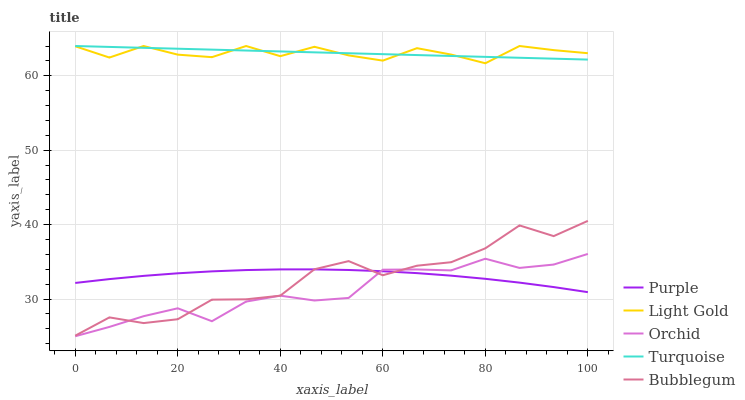Does Orchid have the minimum area under the curve?
Answer yes or no. Yes. Does Turquoise have the maximum area under the curve?
Answer yes or no. Yes. Does Light Gold have the minimum area under the curve?
Answer yes or no. No. Does Light Gold have the maximum area under the curve?
Answer yes or no. No. Is Turquoise the smoothest?
Answer yes or no. Yes. Is Bubblegum the roughest?
Answer yes or no. Yes. Is Light Gold the smoothest?
Answer yes or no. No. Is Light Gold the roughest?
Answer yes or no. No. Does Orchid have the lowest value?
Answer yes or no. Yes. Does Light Gold have the lowest value?
Answer yes or no. No. Does Light Gold have the highest value?
Answer yes or no. Yes. Does Bubblegum have the highest value?
Answer yes or no. No. Is Bubblegum less than Light Gold?
Answer yes or no. Yes. Is Light Gold greater than Purple?
Answer yes or no. Yes. Does Orchid intersect Purple?
Answer yes or no. Yes. Is Orchid less than Purple?
Answer yes or no. No. Is Orchid greater than Purple?
Answer yes or no. No. Does Bubblegum intersect Light Gold?
Answer yes or no. No. 